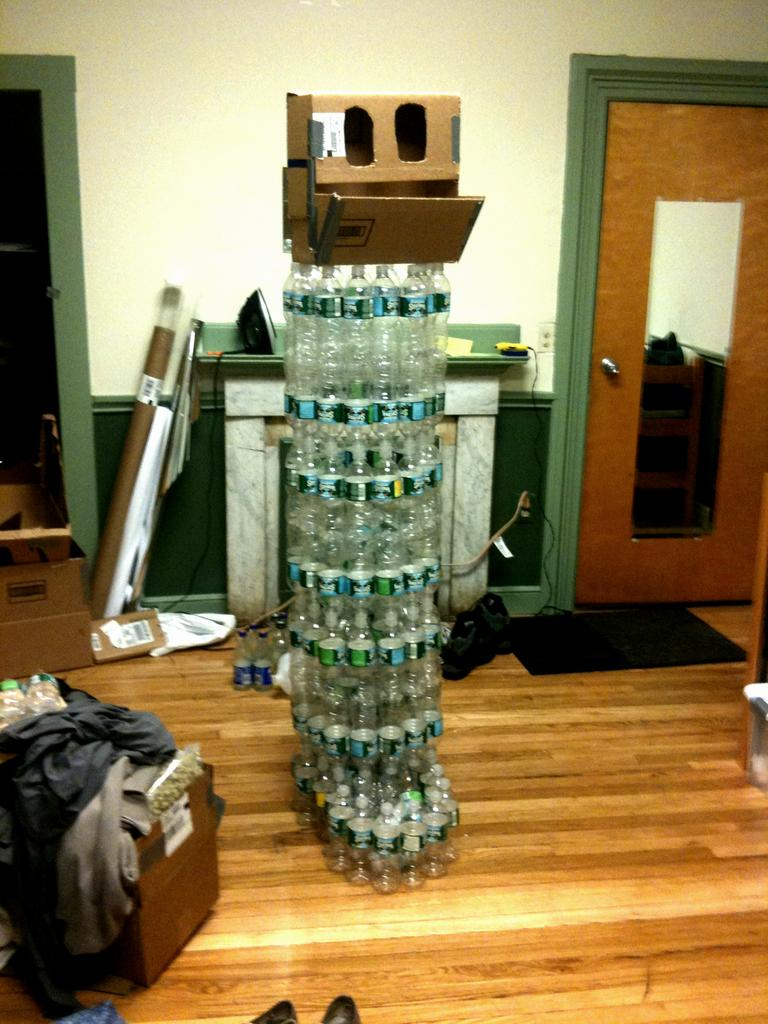What is the main subject in the middle of the image? There is a structure made up of plastic bottles in the middle of the image. How many doors are there on the structure, and where are they located? There are two doors, one on the left and one on the right of the structure. What is behind the doors? There is a wall behind the doors. What can be seen on the left side of the image, near the bottom? Clothes are present on the left side of the image, near the bottom. How many cats are sitting on the yoke in the image? There are no cats or yokes present in the image. 